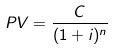<formula> <loc_0><loc_0><loc_500><loc_500>P V = \frac { C } { ( 1 + i ) ^ { n } }</formula> 